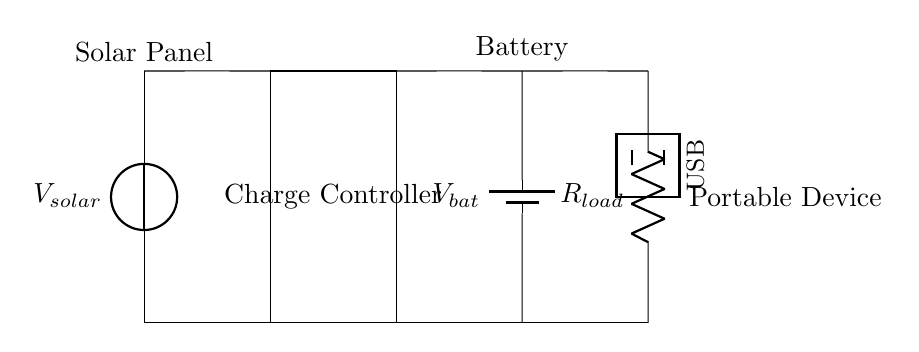what is the type of the circuit's primary power source? The primary power source in this circuit is a solar panel, indicated by the voltage source labeled V_solar at the top left.
Answer: solar panel what is the component responsible for voltage regulation? The charge controller is responsible for regulating the voltage coming from the solar panel to the battery. It is represented by the rectangle labeled "Charge Controller" between the solar panel and the battery.
Answer: charge controller how many batteries are shown in the circuit? There is one battery shown in the circuit, indicated by the symbol labeled V_bat at the right of the charge controller.
Answer: one what is the load component in this circuit? The load component is represented by the resistor labeled R_load connected to the output of the battery. This is indicated by the resistor symbol on the far right, where power is delivered to a portable device.
Answer: R_load what is the purpose of the USB symbol in the circuit? The USB symbol indicates the output interface for connecting a portable device. It shows where the device can draw power from the circuit for charging or operation.
Answer: output interface what is the direction of current flow from the solar panel to the battery? The current flows from the solar panel down through the charge controller to the battery, as represented by the direct connections shown between these components.
Answer: downward how would the circuit behave if the solar panel voltage is lower than the battery voltage? If the solar panel voltage is lower than the battery voltage, the charge controller would prevent current from flowing back into the solar panel, protecting it from potential damage and ensuring that the battery is not discharged.
Answer: no charging 